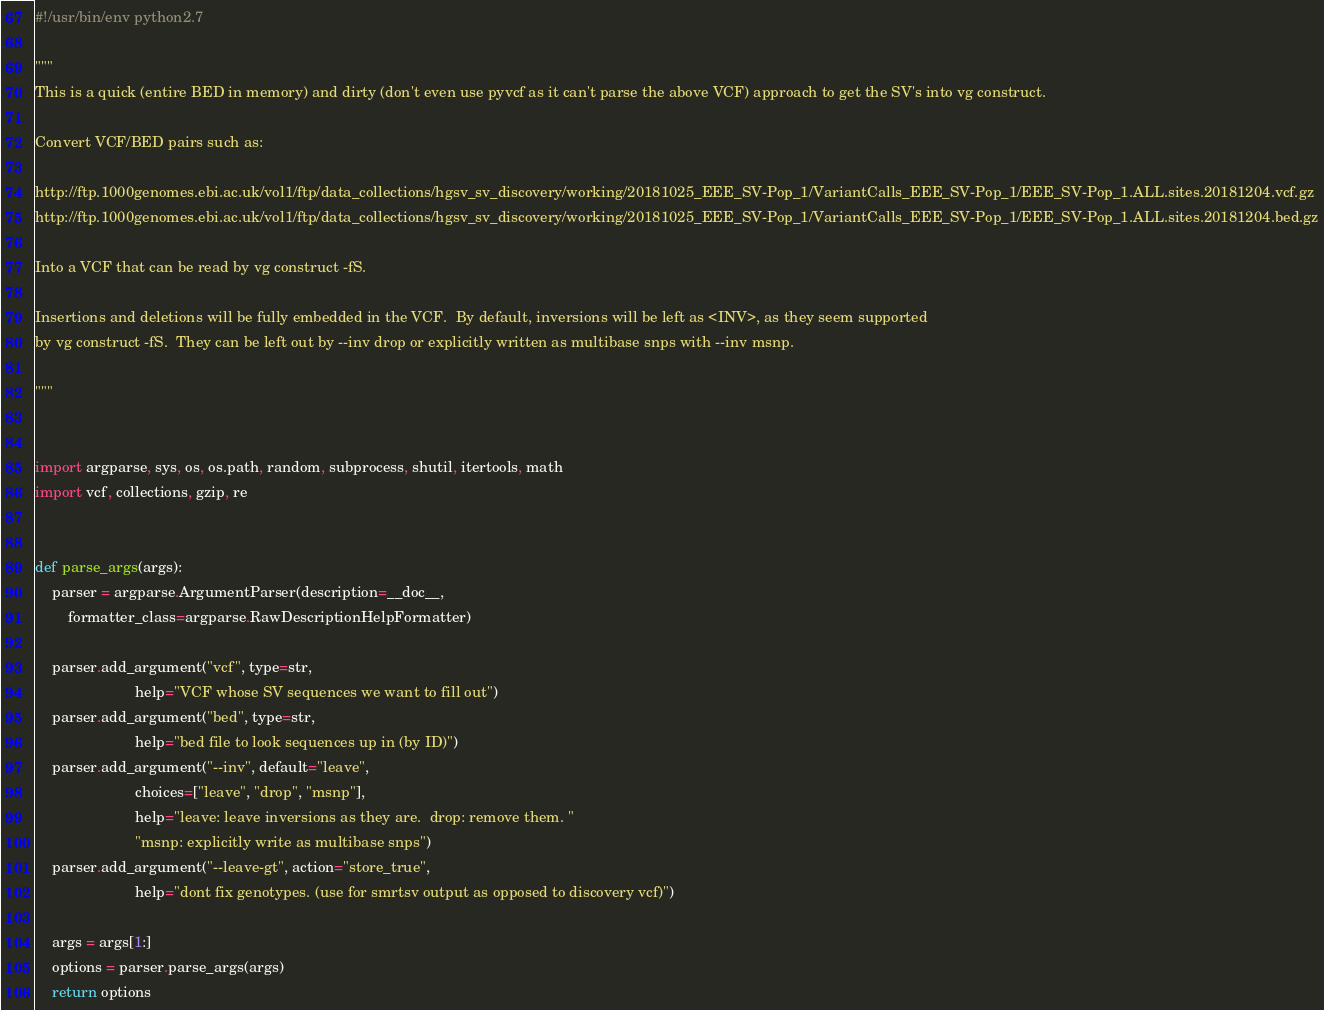<code> <loc_0><loc_0><loc_500><loc_500><_Python_>#!/usr/bin/env python2.7

"""
This is a quick (entire BED in memory) and dirty (don't even use pyvcf as it can't parse the above VCF) approach to get the SV's into vg construct.  

Convert VCF/BED pairs such as:

http://ftp.1000genomes.ebi.ac.uk/vol1/ftp/data_collections/hgsv_sv_discovery/working/20181025_EEE_SV-Pop_1/VariantCalls_EEE_SV-Pop_1/EEE_SV-Pop_1.ALL.sites.20181204.vcf.gz
http://ftp.1000genomes.ebi.ac.uk/vol1/ftp/data_collections/hgsv_sv_discovery/working/20181025_EEE_SV-Pop_1/VariantCalls_EEE_SV-Pop_1/EEE_SV-Pop_1.ALL.sites.20181204.bed.gz

Into a VCF that can be read by vg construct -fS.

Insertions and deletions will be fully embedded in the VCF.  By default, inversions will be left as <INV>, as they seem supported
by vg construct -fS.  They can be left out by --inv drop or explicitly written as multibase snps with --inv msnp.  

"""


import argparse, sys, os, os.path, random, subprocess, shutil, itertools, math
import vcf, collections, gzip, re


def parse_args(args):
    parser = argparse.ArgumentParser(description=__doc__, 
        formatter_class=argparse.RawDescriptionHelpFormatter)

    parser.add_argument("vcf", type=str,
                        help="VCF whose SV sequences we want to fill out")
    parser.add_argument("bed", type=str,
                        help="bed file to look sequences up in (by ID)")
    parser.add_argument("--inv", default="leave",
                        choices=["leave", "drop", "msnp"],
                        help="leave: leave inversions as they are.  drop: remove them. "
                        "msnp: explicitly write as multibase snps")
    parser.add_argument("--leave-gt", action="store_true",
                        help="dont fix genotypes. (use for smrtsv output as opposed to discovery vcf)")
                        
    args = args[1:]
    options = parser.parse_args(args)
    return options
</code> 